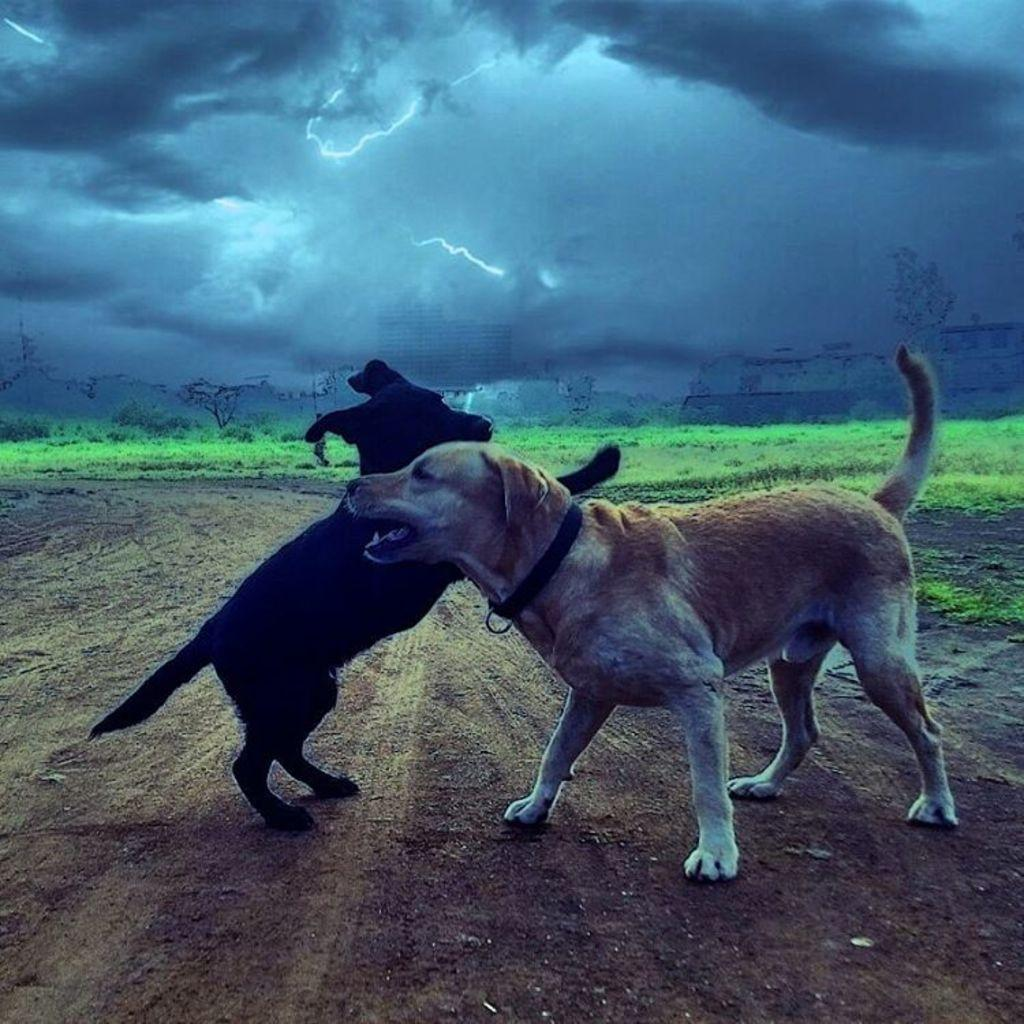How many dogs are present in the image? There are two dogs in the image. What are the dogs doing in the image? The dogs are barking. What can be seen in the background of the image? There is grass and buildings in the background of the image. Who is the servant attending to in the image? There is no servant present in the image. What type of hat is the dog wearing in the image? There are no hats present in the image, and the dogs are not wearing any clothing. 